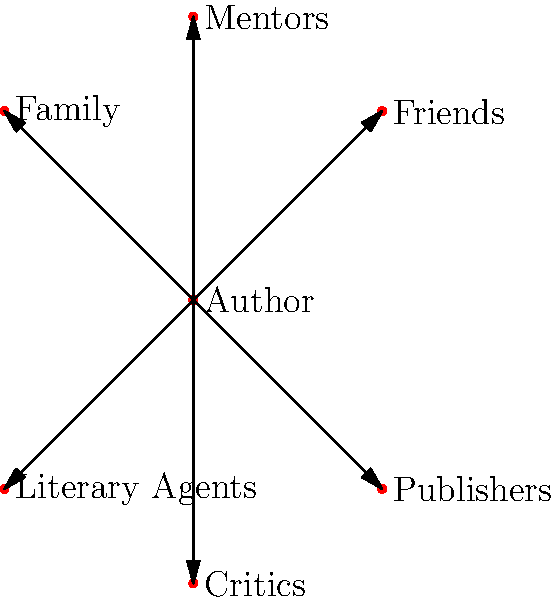Based on the web diagram illustrating the author's social network and relationships, which group is positioned directly above the author and likely represents a significant influence on their writing career? To answer this question, we need to analyze the web diagram of the author's social network:

1. The author is positioned at the center of the diagram.
2. There are six groups connected to the author: Family, Friends, Literary Agents, Publishers, Mentors, and Critics.
3. Each group is positioned in a different direction relative to the author.
4. To find the group directly above the author, we need to look at the position that is vertically aligned and above the central "Author" node.
5. Upon inspection, we can see that the "Mentors" group is positioned directly above the author.
6. Mentors typically play a significant role in shaping an author's writing career by providing guidance, feedback, and support.

Therefore, the group positioned directly above the author, likely representing a significant influence on their writing career, is Mentors.
Answer: Mentors 